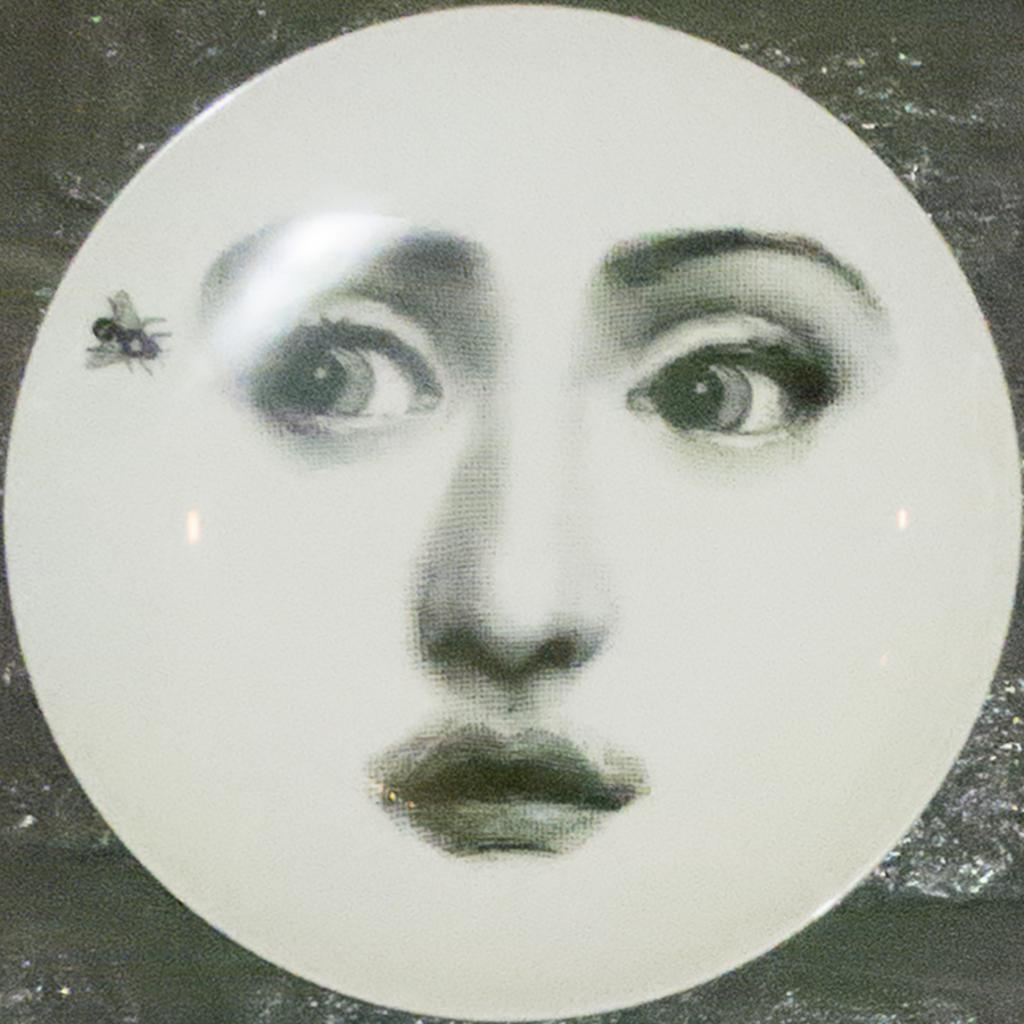What is depicted on the plate in the image? There is a painting on a plate in the image, featuring an insect. What facial features are painted on the plate? Two eyes, a nose, and a mouth are painted on the plate. How many stitches are used to create the curve on the plate? There are no stitches or curves present on the plate, as it is a painted image. 